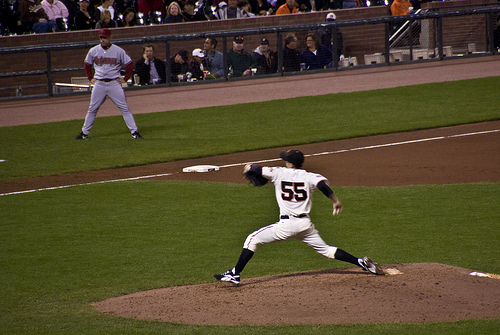What color is the shirt? The shirt is a shade of gray, which contrasts well with the surrounding scene. 